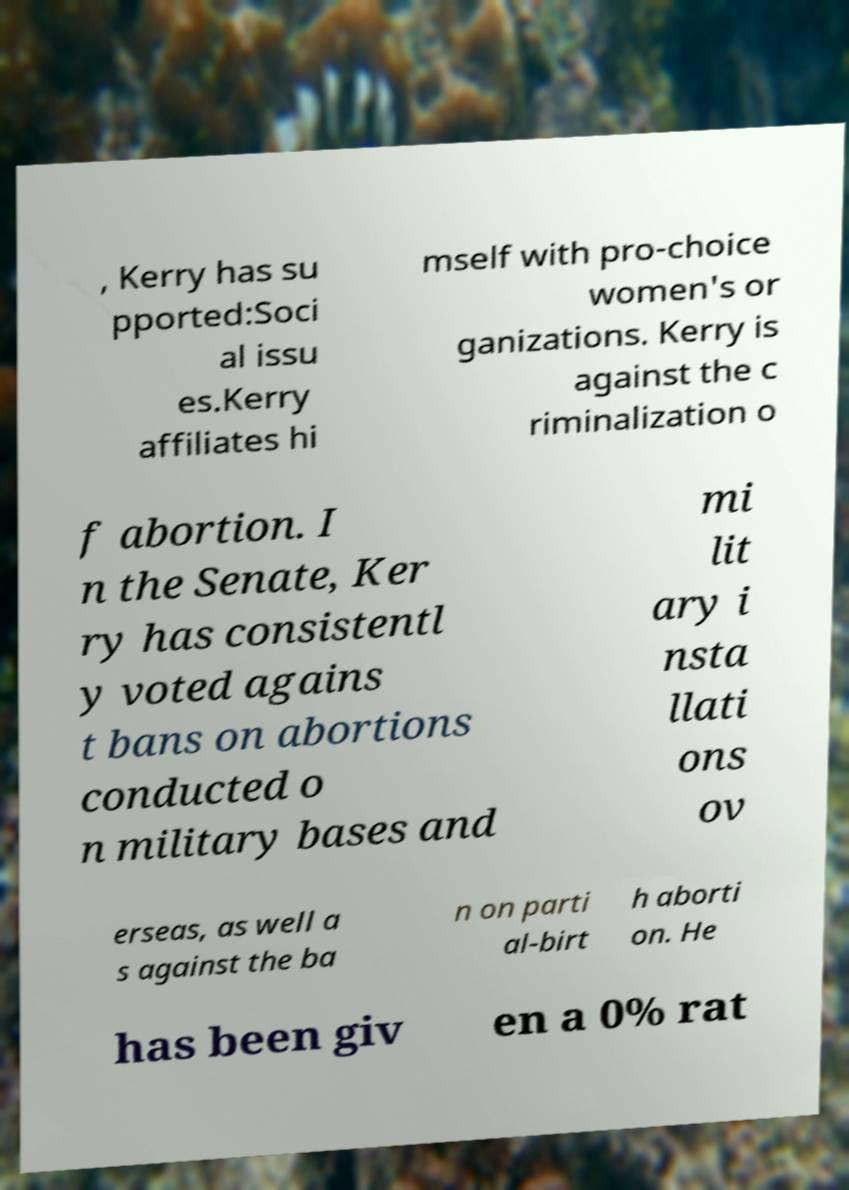Please identify and transcribe the text found in this image. , Kerry has su pported:Soci al issu es.Kerry affiliates hi mself with pro-choice women's or ganizations. Kerry is against the c riminalization o f abortion. I n the Senate, Ker ry has consistentl y voted agains t bans on abortions conducted o n military bases and mi lit ary i nsta llati ons ov erseas, as well a s against the ba n on parti al-birt h aborti on. He has been giv en a 0% rat 